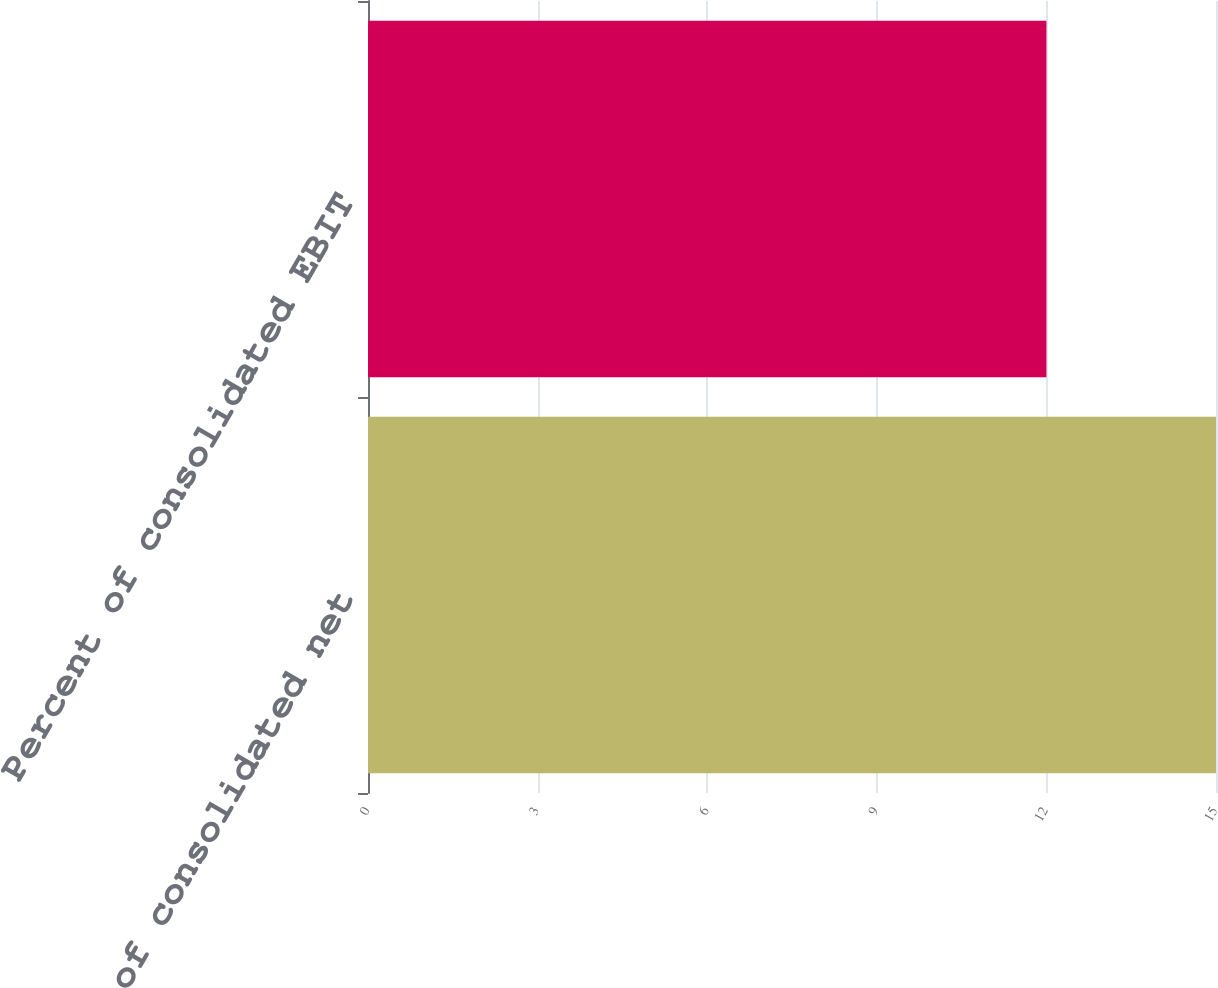<chart> <loc_0><loc_0><loc_500><loc_500><bar_chart><fcel>Percent of consolidated net<fcel>Percent of consolidated EBIT<nl><fcel>15<fcel>12<nl></chart> 